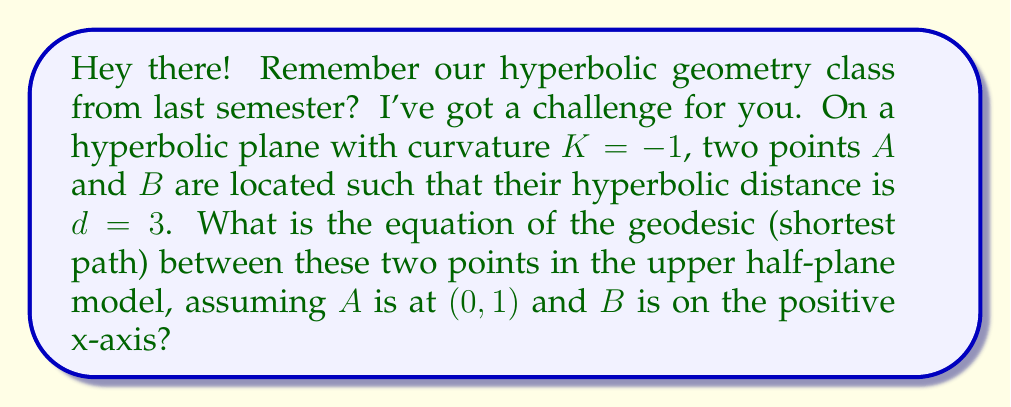Help me with this question. Let's approach this step-by-step:

1) In the upper half-plane model of hyperbolic geometry, geodesics are either vertical lines or semicircles centered on the x-axis.

2) Since point $A$ is at $(0, 1)$ and $B$ is on the positive x-axis, the geodesic will be a semicircle.

3) Let's say $B$ is at $(x, 1)$. We need to find $x$.

4) The hyperbolic distance $d$ between two points $(x_1, y_1)$ and $(x_2, y_2)$ in this model is given by:

   $$d = \text{arcosh}\left(1 + \frac{(x_2 - x_1)^2 + (y_2 - y_1)^2}{2y_1y_2}\right)$$

5) Substituting our values:

   $$3 = \text{arcosh}\left(1 + \frac{x^2 + 0^2}{2 \cdot 1 \cdot 1}\right) = \text{arcosh}\left(1 + \frac{x^2}{2}\right)$$

6) Solving this:

   $$\cosh(3) = 1 + \frac{x^2}{2}$$
   $$\frac{x^2}{2} = \cosh(3) - 1$$
   $$x^2 = 2(\cosh(3) - 1)$$
   $$x = \sqrt{2(\cosh(3) - 1)} \approx 3.525$$

7) Now that we have both points, we can find the equation of the semicircle. The general equation is:

   $$(x - h)^2 + y^2 = r^2$$

   where $(h, 0)$ is the center and $r$ is the radius.

8) The center will be halfway between $A$ and $B$ on the x-axis, so $h = x/2 \approx 1.7625$.

9) The radius will be the distance from the center to either point:

   $$r = \sqrt{h^2 + 1^2} \approx 2.0252$$

10) Therefore, the equation of the geodesic is:

    $$(x - 1.7625)^2 + y^2 = 4.1014$$
Answer: $(x - \frac{\sqrt{2(\cosh(3) - 1)}}{2})^2 + y^2 = (\frac{\sqrt{2(\cosh(3) - 1)}}{2})^2 + 1$ 